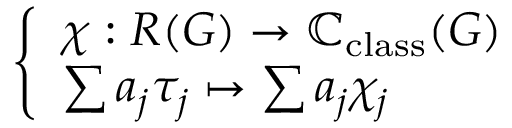Convert formula to latex. <formula><loc_0><loc_0><loc_500><loc_500>\left \{ \begin{array} { l l } { \chi \colon R ( G ) \to \mathbb { C } _ { c l a s s } ( G ) } \\ { \sum a _ { j } \tau _ { j } \mapsto \sum a _ { j } \chi _ { j } } \end{array}</formula> 